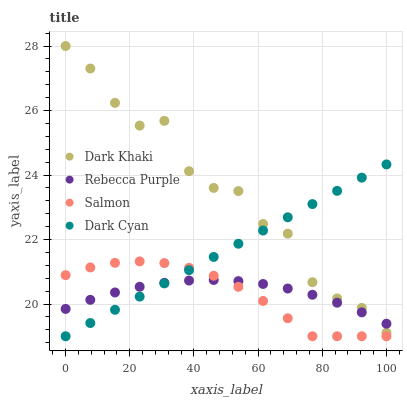Does Salmon have the minimum area under the curve?
Answer yes or no. Yes. Does Dark Khaki have the maximum area under the curve?
Answer yes or no. Yes. Does Dark Cyan have the minimum area under the curve?
Answer yes or no. No. Does Dark Cyan have the maximum area under the curve?
Answer yes or no. No. Is Dark Cyan the smoothest?
Answer yes or no. Yes. Is Dark Khaki the roughest?
Answer yes or no. Yes. Is Salmon the smoothest?
Answer yes or no. No. Is Salmon the roughest?
Answer yes or no. No. Does Dark Cyan have the lowest value?
Answer yes or no. Yes. Does Rebecca Purple have the lowest value?
Answer yes or no. No. Does Dark Khaki have the highest value?
Answer yes or no. Yes. Does Dark Cyan have the highest value?
Answer yes or no. No. Is Salmon less than Dark Khaki?
Answer yes or no. Yes. Is Dark Khaki greater than Salmon?
Answer yes or no. Yes. Does Dark Cyan intersect Rebecca Purple?
Answer yes or no. Yes. Is Dark Cyan less than Rebecca Purple?
Answer yes or no. No. Is Dark Cyan greater than Rebecca Purple?
Answer yes or no. No. Does Salmon intersect Dark Khaki?
Answer yes or no. No. 